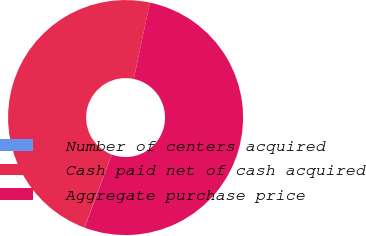<chart> <loc_0><loc_0><loc_500><loc_500><pie_chart><fcel>Number of centers acquired<fcel>Cash paid net of cash acquired<fcel>Aggregate purchase price<nl><fcel>0.03%<fcel>47.61%<fcel>52.36%<nl></chart> 